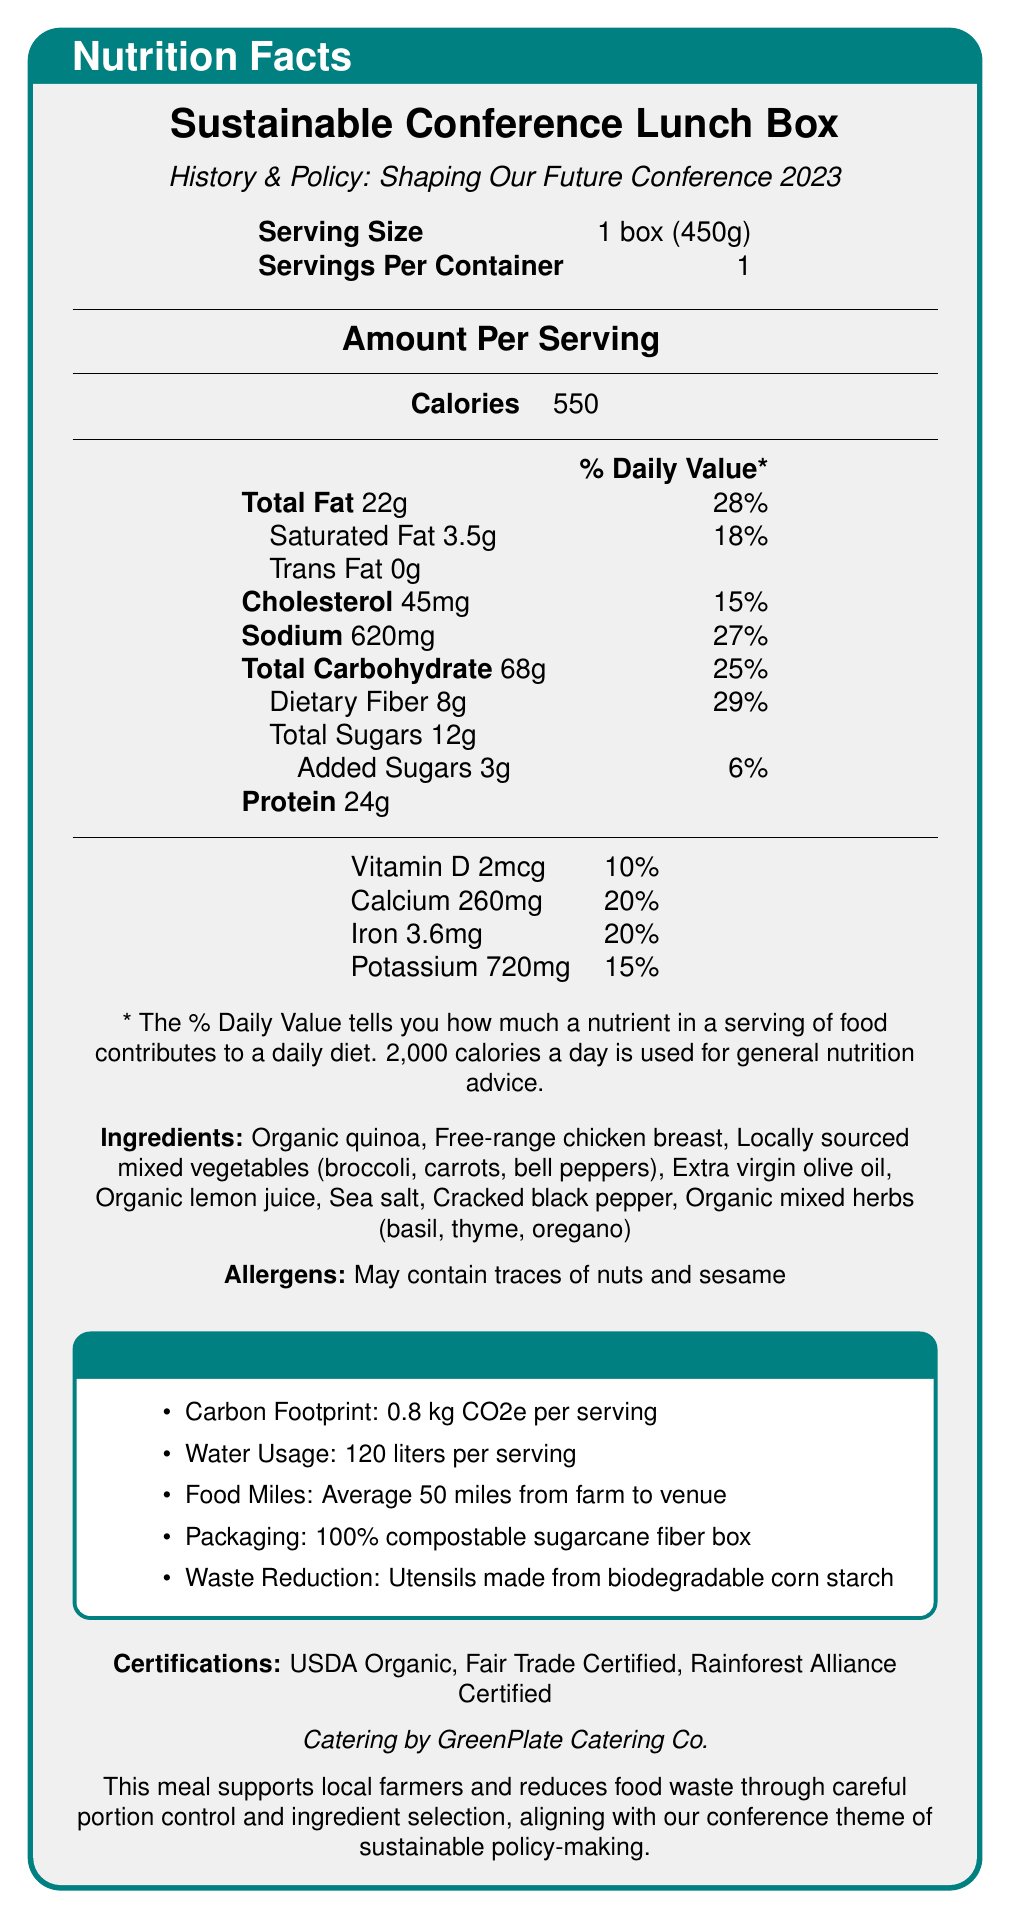What is the serving size of the Sustainable Conference Lunch Box? The serving size is listed as 1 box (450g) under the Serving Size section.
Answer: 1 box (450g) How many calories are in one serving of the Sustainable Conference Lunch Box? The Calories section specifically states that there are 550 calories per serving.
Answer: 550 What is the total fat content in one serving? The Total Fat content is listed as 22g in the Amount Per Serving section.
Answer: 22g What percentage of the daily value does the saturated fat content represent? Saturated Fat is listed as 3.5g which represents 18% of the daily value in the Amount Per Serving section.
Answer: 18% How many grams of protein are in the Sustainable Conference Lunch Box? The document states there are 24g of protein.
Answer: 24g Which certifications does the Sustainable Conference Lunch Box have? A. USDA Organic B. Rainforest Alliance Certified C. Non-GMO Project Verified D. Fair Trade Certified The document lists USDA Organic, Fair Trade Certified, and Rainforest Alliance Certified under certifications.
Answer: A, B, D What is the carbon footprint per serving? The Sustainability Information box mentions that the carbon footprint is 0.8 kg CO2e per serving.
Answer: 0.8 kg CO2e per serving What ingredients are included in the Sustainable Conference Lunch Box? These ingredients are listed under the Ingredients section.
Answer: Organic quinoa, Free-range chicken breast, Locally sourced mixed vegetables (broccoli, carrots, bell peppers), Extra virgin olive oil, Organic lemon juice, Sea salt, Cracked black pepper, Organic mixed herbs (basil, thyme, oregano) True or False: The packaging of the Sustainable Conference Lunch Box is biodegradable. In the Sustainability Information section, it states that the packaging is a 100% compostable sugarcane fiber box.
Answer: True Who is providing the catering for the conference? The document states “Catering by GreenPlate Catering Co.” near the bottom.
Answer: GreenPlate Catering Co. List three benefits mentioned in the Sustainability Information section regarding the packaging or utensils. These points are mentioned under the Sustainability Information section.
Answer: 100% compostable sugarcane fiber box, utensils made from biodegradable corn starch, average food miles of 50 miles How much water is used per serving of the Sustainable Conference Lunch Box? The Sustainability Information section lists water usage as 120 liters per serving.
Answer: 120 liters per serving Describe the main focus of the document. The document aims to inform conference attendees about the health and ecological impact of their meal, aligning with the conference's theme of sustainable policy-making.
Answer: The document provides detailed nutritional and sustainability information about the Sustainable Conference Lunch Box which is being offered by GreenPlate Catering Co. for the History & Policy: Shaping Our Future Conference 2023. It includes data on serving size, calorie content, macronutrients, vitamins, ingredients, allergens, and certifications, along with sustainability metrics like carbon footprint, water usage, and packaging materials. Does the Sustainable Conference Lunch Box contain any added sugars? If so, how many grams? The document lists added sugars as 3g under the Amount Per Serving section.
Answer: Yes, 3g What is the average food miles from farm to venue for the ingredients? This information is provided in the Sustainability Information section as "average 50 miles from farm to venue".
Answer: 50 miles Which vitamin is present in the amount of 2mcg per serving? The document lists Vitamin D as 2mcg in the Amount Per Serving section.
Answer: Vitamin D How does this meal support the conference's theme of sustainable policy-making? The text near the bottom states that the meal supports local farmers, reduces food waste, and aligns with sustainable policy-making.
Answer: It supports local farmers, reduces food waste through careful portion control and ingredient selection, and uses eco-friendly packaging. What is the total amount of dietary fiber in the Sustainable Conference Lunch Box? The document lists the dietary fiber content as 8g in the Amount Per Serving section.
Answer: 8g Which of the ingredients may cause allergies? The Allergens section states the meal "may contain traces of nuts and sesame."
Answer: Traces of nuts and sesame How much potassium is present in the Sustainable Conference Lunch Box? The document lists potassium as 720mg in the Amount Per Serving section.
Answer: 720mg What is the name of the conference mentioned in the document? A. Future Policy Conference B. History & Policy: Shaping Our Future Conference 2023 C. Sustainability Summit 2023 The name of the conference is stated twice: near the top under the product name and in the introduction of the document.
Answer: B. History & Policy: Shaping Our Future Conference 2023 Are non-GMO ingredients used in the Sustainable Conference Lunch Box? The document does not provide specific information regarding non-GMO ingredients.
Answer: Cannot be determined 